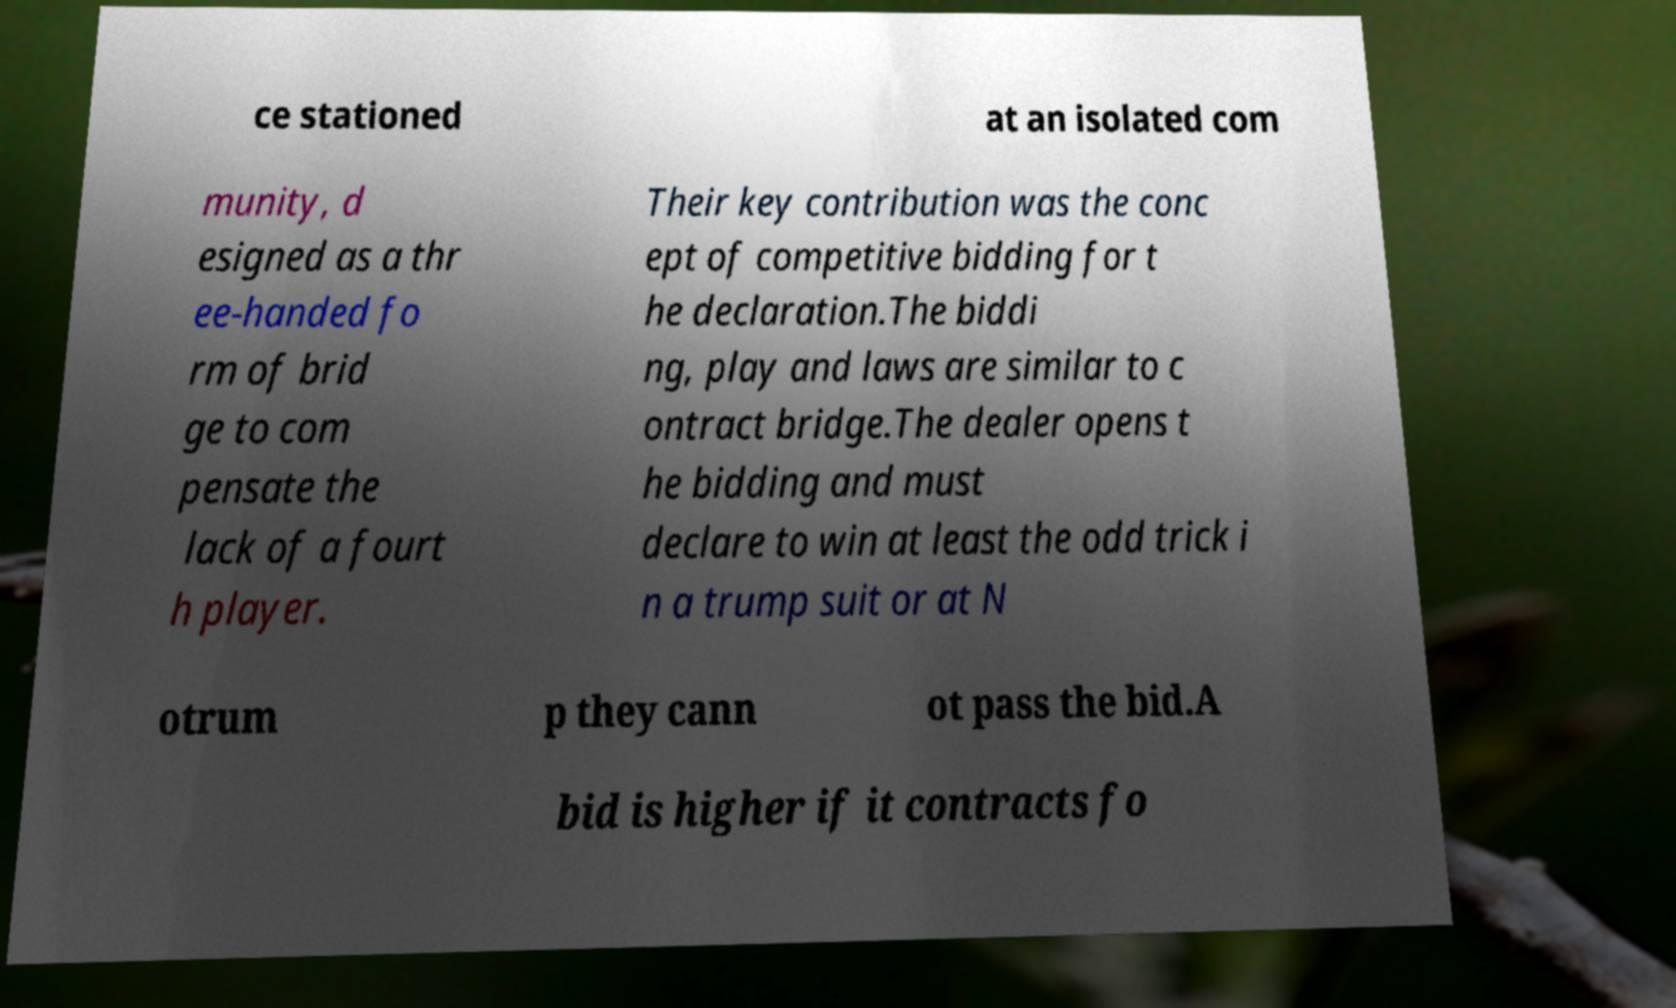What messages or text are displayed in this image? I need them in a readable, typed format. ce stationed at an isolated com munity, d esigned as a thr ee-handed fo rm of brid ge to com pensate the lack of a fourt h player. Their key contribution was the conc ept of competitive bidding for t he declaration.The biddi ng, play and laws are similar to c ontract bridge.The dealer opens t he bidding and must declare to win at least the odd trick i n a trump suit or at N otrum p they cann ot pass the bid.A bid is higher if it contracts fo 